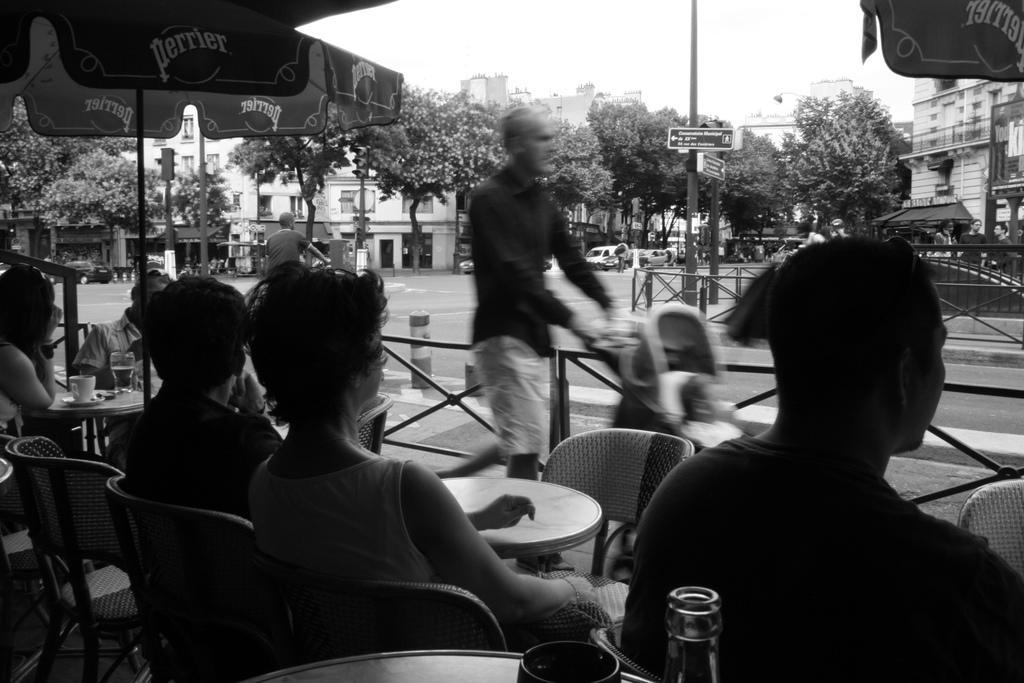In one or two sentences, can you explain what this image depicts? In this picture we can see some people sitting on chair and some are walking carrying stroller with their hands and in front of them there is table and on table we can see glass, cup, saucer and in background we can see trees, building, pole, sign board, cars. 